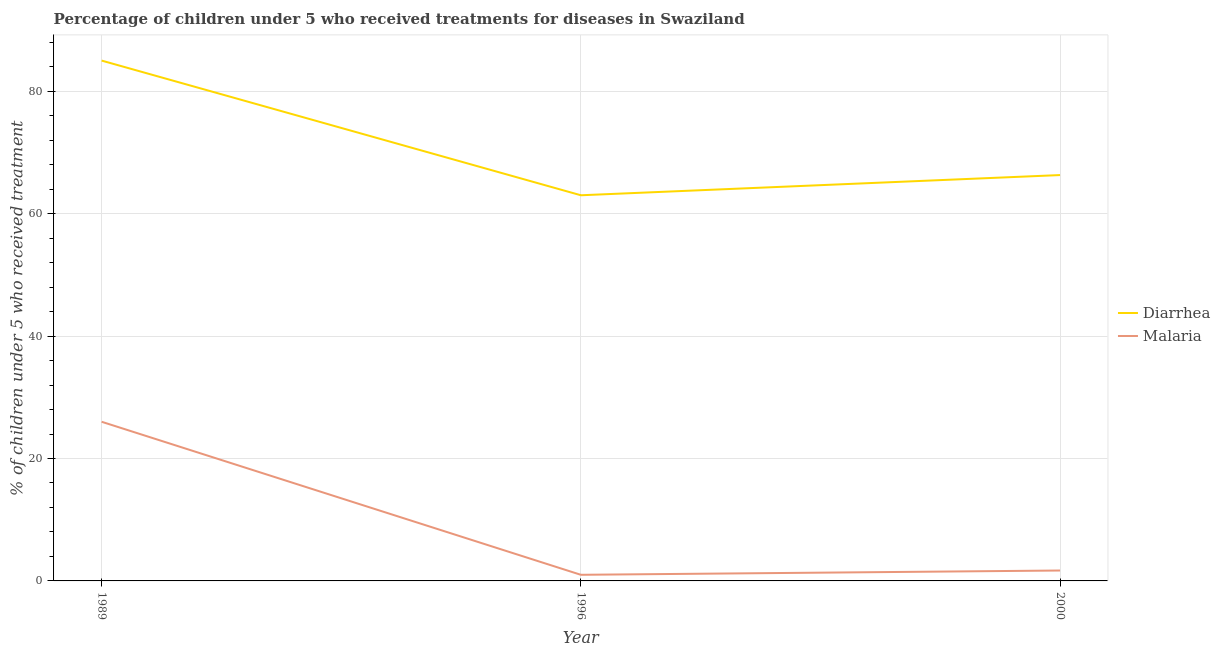Across all years, what is the maximum percentage of children who received treatment for malaria?
Keep it short and to the point. 26. Across all years, what is the minimum percentage of children who received treatment for malaria?
Keep it short and to the point. 1. In which year was the percentage of children who received treatment for diarrhoea minimum?
Provide a short and direct response. 1996. What is the total percentage of children who received treatment for diarrhoea in the graph?
Provide a short and direct response. 214.3. What is the difference between the percentage of children who received treatment for malaria in 1989 and that in 1996?
Your answer should be very brief. 25. What is the difference between the percentage of children who received treatment for diarrhoea in 1989 and the percentage of children who received treatment for malaria in 2000?
Keep it short and to the point. 83.3. What is the average percentage of children who received treatment for malaria per year?
Make the answer very short. 9.57. In the year 1989, what is the difference between the percentage of children who received treatment for diarrhoea and percentage of children who received treatment for malaria?
Provide a succinct answer. 59. What is the ratio of the percentage of children who received treatment for malaria in 1989 to that in 2000?
Keep it short and to the point. 15.29. What is the difference between the highest and the second highest percentage of children who received treatment for diarrhoea?
Offer a terse response. 18.7. In how many years, is the percentage of children who received treatment for malaria greater than the average percentage of children who received treatment for malaria taken over all years?
Your response must be concise. 1. Is the percentage of children who received treatment for malaria strictly greater than the percentage of children who received treatment for diarrhoea over the years?
Your response must be concise. No. Is the percentage of children who received treatment for malaria strictly less than the percentage of children who received treatment for diarrhoea over the years?
Ensure brevity in your answer.  Yes. How many lines are there?
Your answer should be very brief. 2. How are the legend labels stacked?
Your answer should be very brief. Vertical. What is the title of the graph?
Provide a short and direct response. Percentage of children under 5 who received treatments for diseases in Swaziland. Does "Male labor force" appear as one of the legend labels in the graph?
Give a very brief answer. No. What is the label or title of the Y-axis?
Your response must be concise. % of children under 5 who received treatment. What is the % of children under 5 who received treatment of Malaria in 1989?
Make the answer very short. 26. What is the % of children under 5 who received treatment in Malaria in 1996?
Your answer should be very brief. 1. What is the % of children under 5 who received treatment of Diarrhea in 2000?
Give a very brief answer. 66.3. What is the % of children under 5 who received treatment in Malaria in 2000?
Your answer should be very brief. 1.7. What is the total % of children under 5 who received treatment in Diarrhea in the graph?
Make the answer very short. 214.3. What is the total % of children under 5 who received treatment in Malaria in the graph?
Your answer should be compact. 28.7. What is the difference between the % of children under 5 who received treatment in Diarrhea in 1989 and that in 1996?
Your answer should be compact. 22. What is the difference between the % of children under 5 who received treatment of Malaria in 1989 and that in 1996?
Make the answer very short. 25. What is the difference between the % of children under 5 who received treatment of Malaria in 1989 and that in 2000?
Your response must be concise. 24.3. What is the difference between the % of children under 5 who received treatment of Diarrhea in 1989 and the % of children under 5 who received treatment of Malaria in 1996?
Offer a very short reply. 84. What is the difference between the % of children under 5 who received treatment of Diarrhea in 1989 and the % of children under 5 who received treatment of Malaria in 2000?
Your answer should be very brief. 83.3. What is the difference between the % of children under 5 who received treatment of Diarrhea in 1996 and the % of children under 5 who received treatment of Malaria in 2000?
Offer a terse response. 61.3. What is the average % of children under 5 who received treatment of Diarrhea per year?
Give a very brief answer. 71.43. What is the average % of children under 5 who received treatment of Malaria per year?
Give a very brief answer. 9.57. In the year 1989, what is the difference between the % of children under 5 who received treatment of Diarrhea and % of children under 5 who received treatment of Malaria?
Provide a succinct answer. 59. In the year 2000, what is the difference between the % of children under 5 who received treatment in Diarrhea and % of children under 5 who received treatment in Malaria?
Offer a terse response. 64.6. What is the ratio of the % of children under 5 who received treatment in Diarrhea in 1989 to that in 1996?
Keep it short and to the point. 1.35. What is the ratio of the % of children under 5 who received treatment in Malaria in 1989 to that in 1996?
Give a very brief answer. 26. What is the ratio of the % of children under 5 who received treatment in Diarrhea in 1989 to that in 2000?
Ensure brevity in your answer.  1.28. What is the ratio of the % of children under 5 who received treatment in Malaria in 1989 to that in 2000?
Provide a succinct answer. 15.29. What is the ratio of the % of children under 5 who received treatment in Diarrhea in 1996 to that in 2000?
Provide a short and direct response. 0.95. What is the ratio of the % of children under 5 who received treatment of Malaria in 1996 to that in 2000?
Keep it short and to the point. 0.59. What is the difference between the highest and the second highest % of children under 5 who received treatment in Diarrhea?
Ensure brevity in your answer.  18.7. What is the difference between the highest and the second highest % of children under 5 who received treatment of Malaria?
Ensure brevity in your answer.  24.3. What is the difference between the highest and the lowest % of children under 5 who received treatment in Malaria?
Your answer should be compact. 25. 